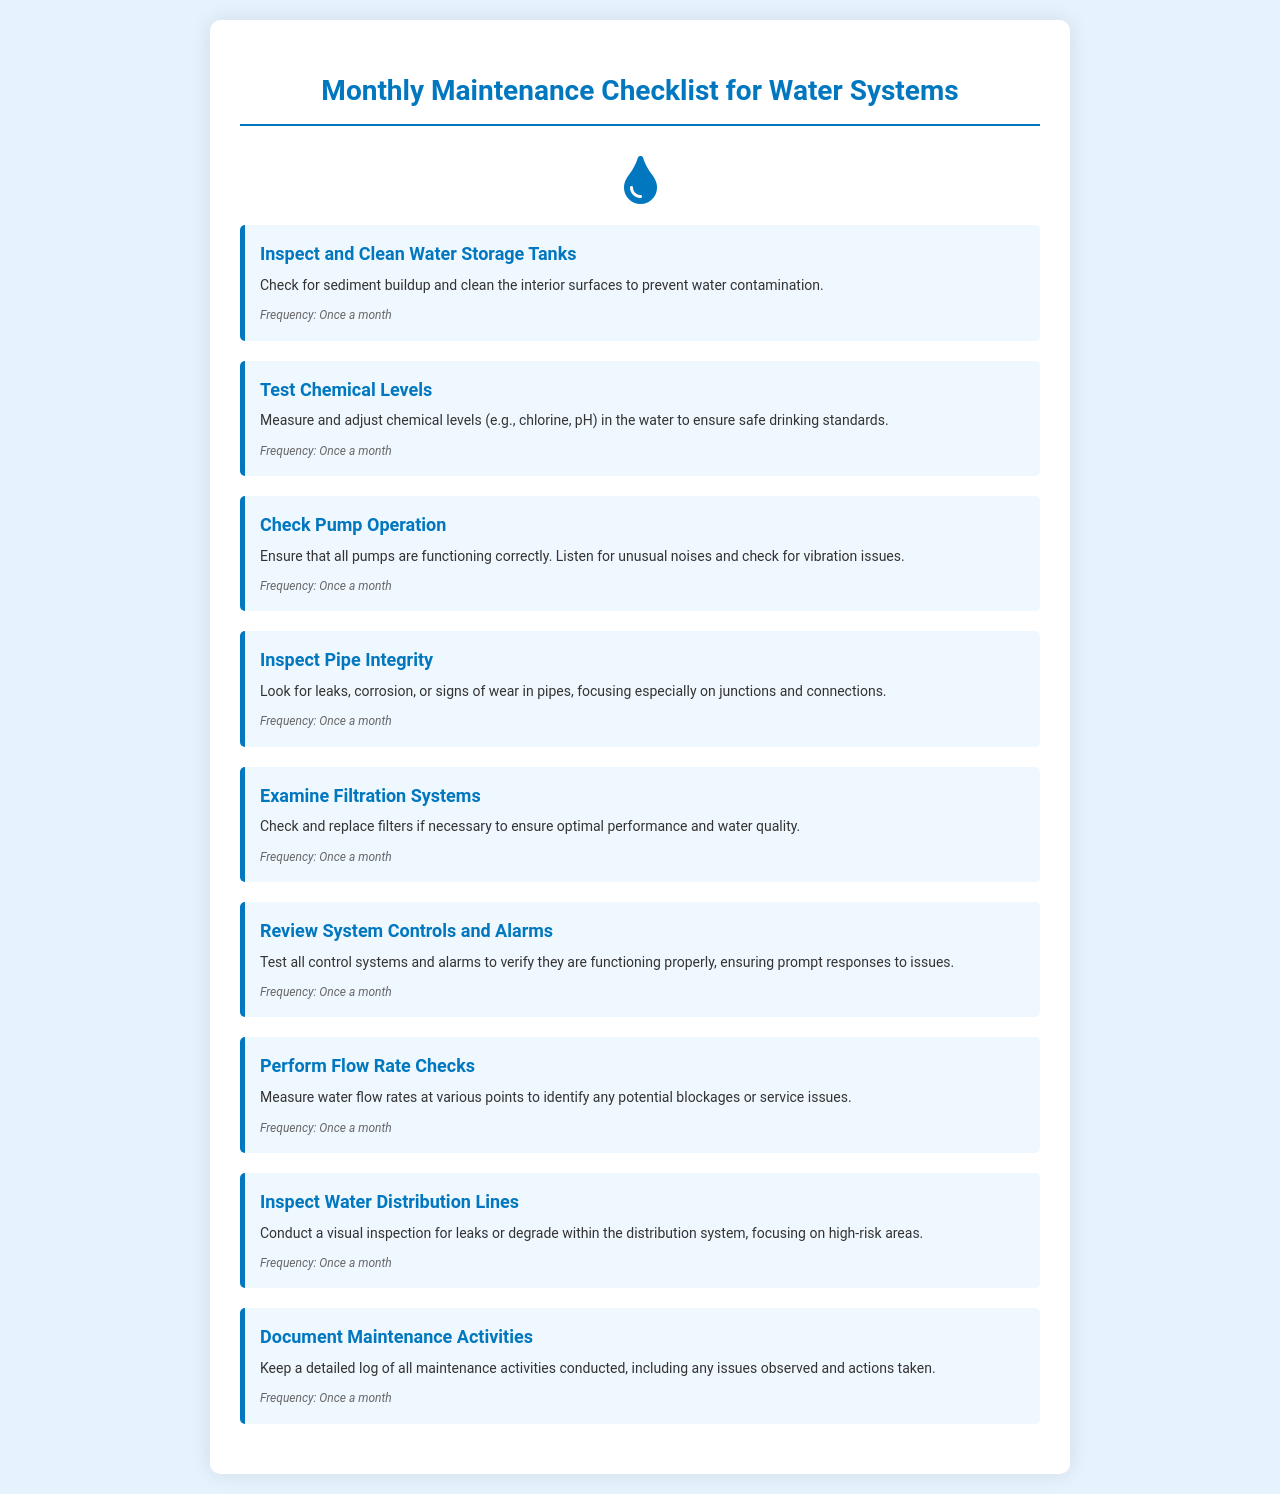What is the first task listed in the checklist? The first task in the checklist is to Inspect and Clean Water Storage Tanks, which is the heading of the first task section.
Answer: Inspect and Clean Water Storage Tanks How often should the chemical levels be tested? The frequency stated for testing chemical levels is "Once a month," which is mentioned in the frequency section for that task.
Answer: Once a month What task involves checking for leaks and corrosion in pipes? The task that includes checking for leaks and corrosion in pipes is titled Inspect Pipe Integrity, as described in the task details.
Answer: Inspect Pipe Integrity How many tasks are listed in total? The document lists a total of 9 tasks related to water system maintenance, as indicated by the number of task sections presented.
Answer: 9 What is the purpose of documenting maintenance activities? Documenting maintenance activities helps maintain a detailed log of all maintenance actions, ensuring issues are tracked and resolutions noted.
Answer: Keep a detailed log Which task focuses on the filtration systems? The task that focuses specifically on the filtration systems is named Examine Filtration Systems.
Answer: Examine Filtration Systems What is the task related to system controls and alarms? The task related to system controls and alarms is titled Review System Controls and Alarms, emphasizing its oversight function.
Answer: Review System Controls and Alarms What is the frequency of performing flow rate checks? The frequency for performing flow rate checks is designated as "Once a month," as highlighted in the task details.
Answer: Once a month 